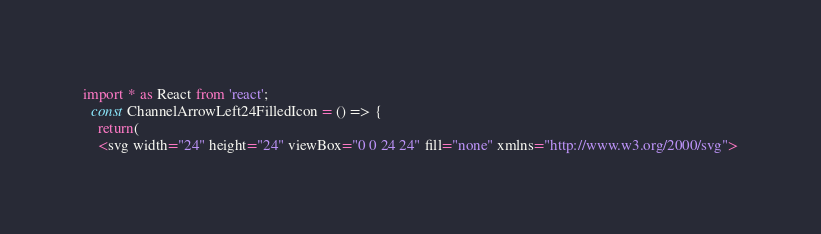<code> <loc_0><loc_0><loc_500><loc_500><_TypeScript_>import * as React from 'react';
  const ChannelArrowLeft24FilledIcon = () => {
    return(
    <svg width="24" height="24" viewBox="0 0 24 24" fill="none" xmlns="http://www.w3.org/2000/svg"></code> 